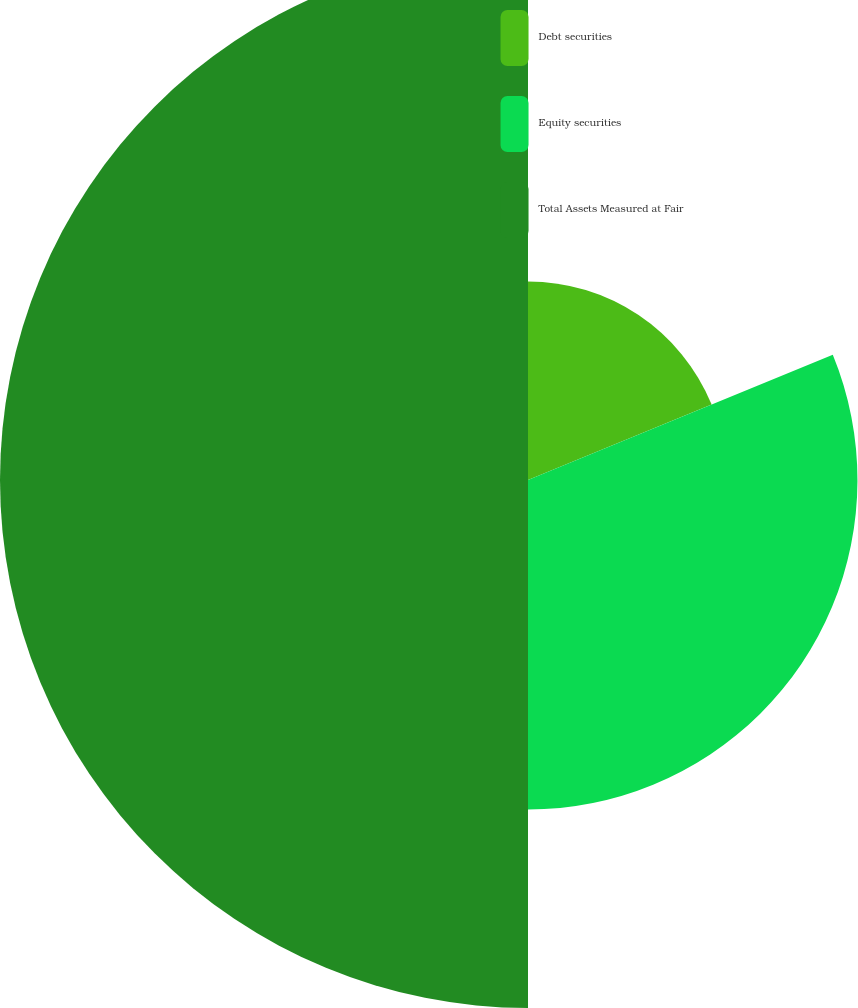Convert chart to OTSL. <chart><loc_0><loc_0><loc_500><loc_500><pie_chart><fcel>Debt securities<fcel>Equity securities<fcel>Total Assets Measured at Fair<nl><fcel>18.8%<fcel>31.2%<fcel>50.0%<nl></chart> 